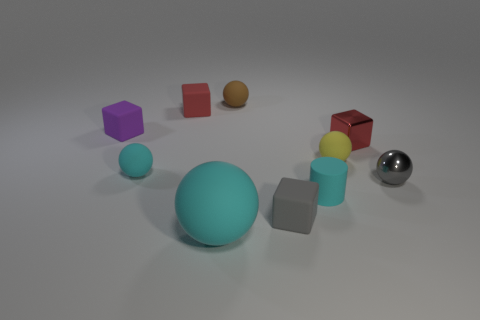Do the tiny brown rubber thing and the tiny yellow matte thing have the same shape?
Your answer should be very brief. Yes. What size is the gray ball?
Offer a terse response. Small. There is a block that is in front of the metal block; is it the same size as the cyan rubber thing that is in front of the tiny gray matte thing?
Your response must be concise. No. What is the size of the purple rubber object that is the same shape as the small gray rubber object?
Provide a short and direct response. Small. There is a red shiny thing; is its size the same as the metallic object in front of the yellow object?
Your answer should be compact. Yes. There is a small cyan cylinder that is in front of the purple cube; is there a small red metal cube that is on the left side of it?
Offer a terse response. No. There is a tiny red object that is behind the purple rubber block; what is its shape?
Your answer should be compact. Cube. What material is the other tiny block that is the same color as the metallic cube?
Your answer should be very brief. Rubber. There is a tiny sphere that is on the left side of the matte ball in front of the cyan cylinder; what is its color?
Your answer should be very brief. Cyan. Is the brown object the same size as the purple thing?
Offer a very short reply. Yes. 